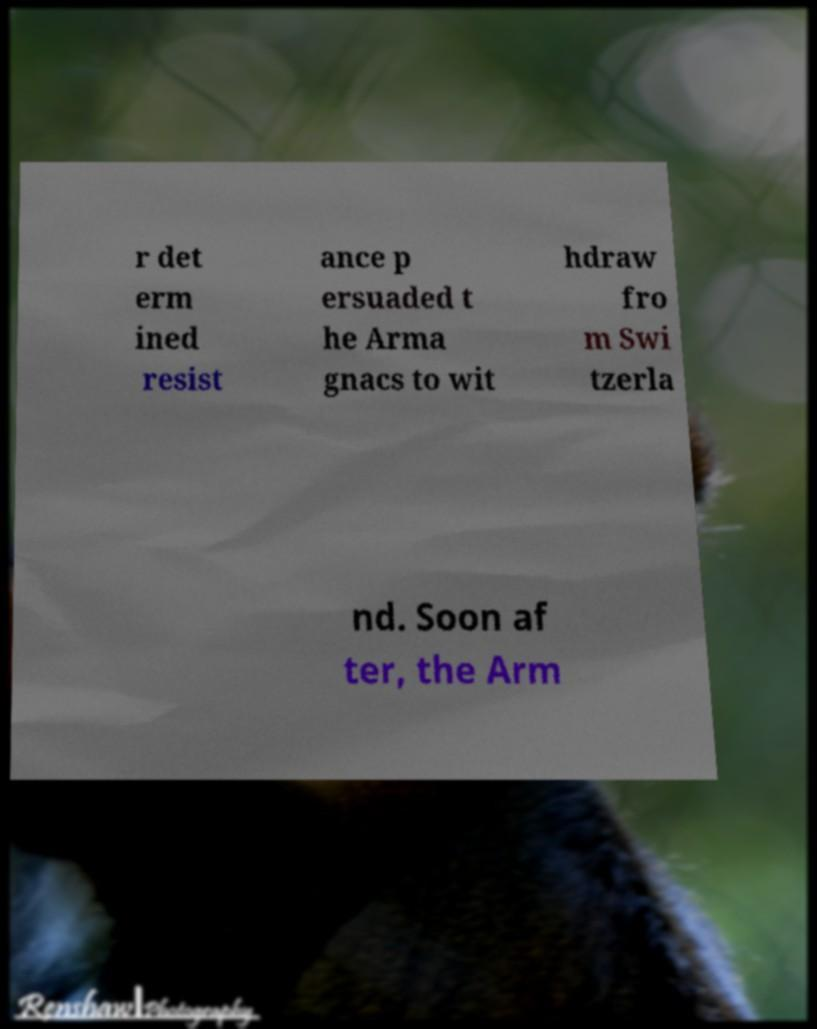Please read and relay the text visible in this image. What does it say? r det erm ined resist ance p ersuaded t he Arma gnacs to wit hdraw fro m Swi tzerla nd. Soon af ter, the Arm 